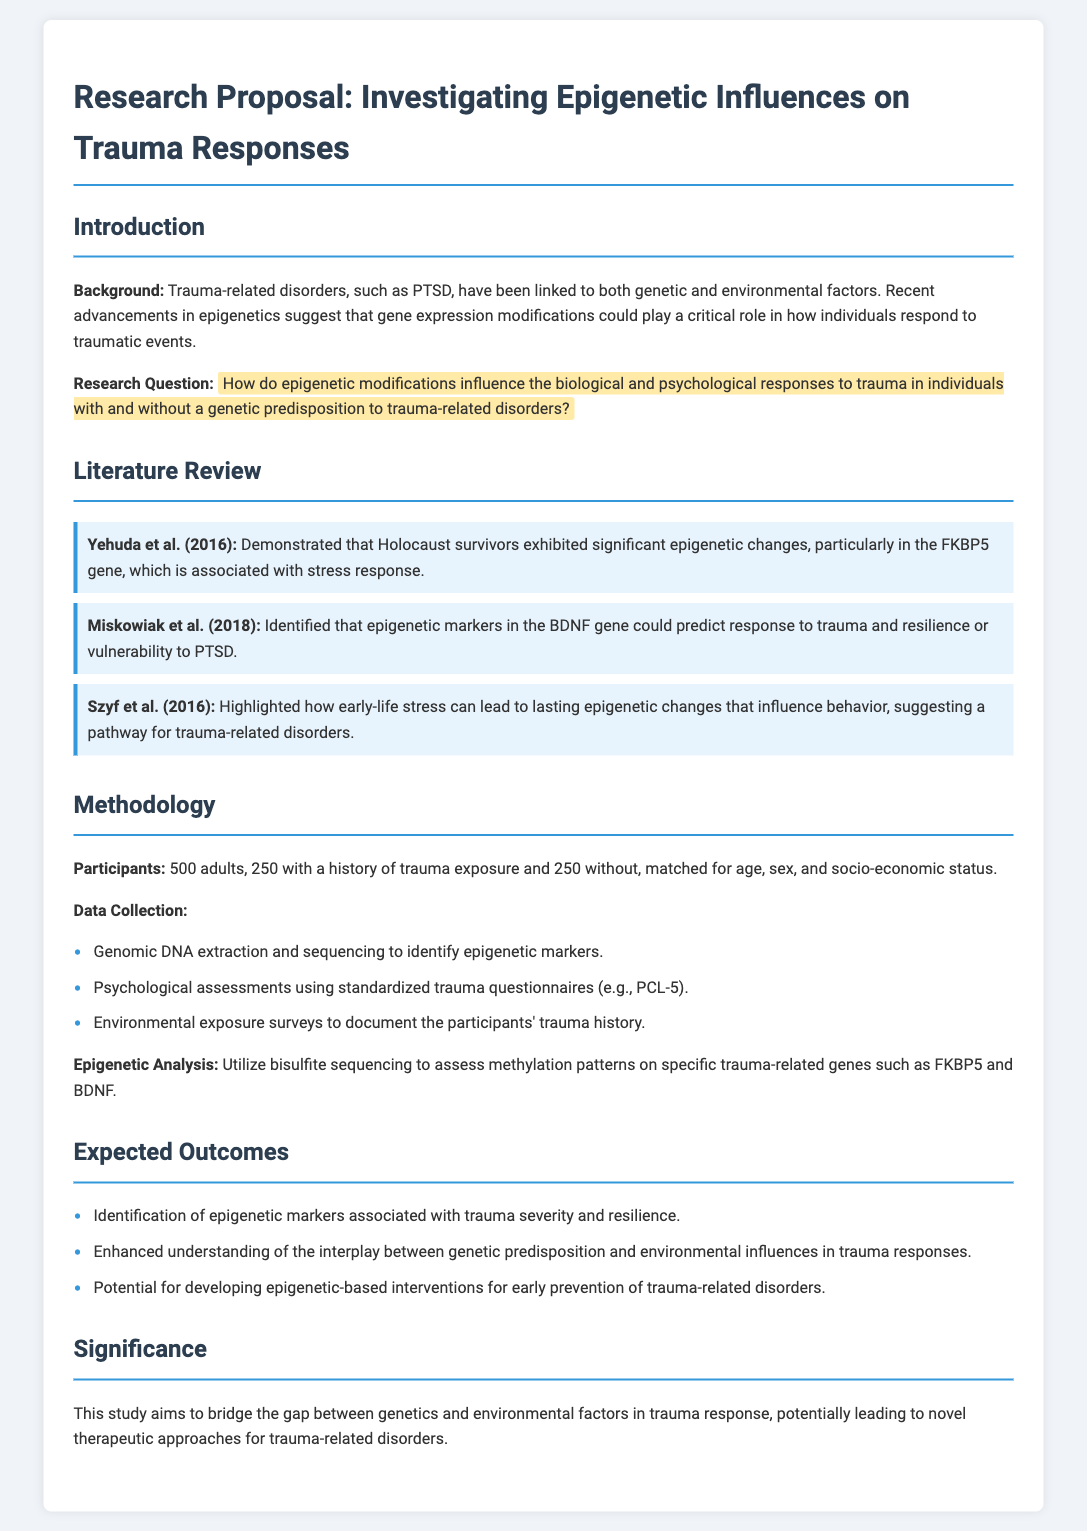What is the title of the research proposal? The title is stated at the top of the document and describes the focus of the study.
Answer: Investigating Epigenetic Influences on Trauma Responses Who is one of the authors mentioned in the literature review? The authors of the studies reviewed are referenced throughout the document, identifying significant research in the field.
Answer: Yehuda What is the sample size of participants in the study? The sample size is provided in the methodology section, specifying the number of participants involved in the research.
Answer: 500 adults Which gene is specifically mentioned in relation to stress response? This information comes from the literature review where significant epigenetic changes are associated with a particular gene.
Answer: FKBP5 What type of analysis will be used for epigenetic markers? The method of analysis is described in the methodology section, detailing the technique used to assess gene modification.
Answer: Bisulfite sequencing What is one expected outcome of the study? Expected outcomes are listed, indicating what the research aims to discover regarding trauma responses.
Answer: Identification of epigenetic markers What is the research question posed in the proposal? The research question is highlighted in the introduction, defining the focus of the study on epigenetic influences.
Answer: How do epigenetic modifications influence the biological and psychological responses to trauma in individuals with and without a genetic predisposition to trauma-related disorders? What are the matching criteria for participants? The methodology outlines specific criteria for selecting participants, addressing factors that need to be considered.
Answer: Age, sex, and socio-economic status 